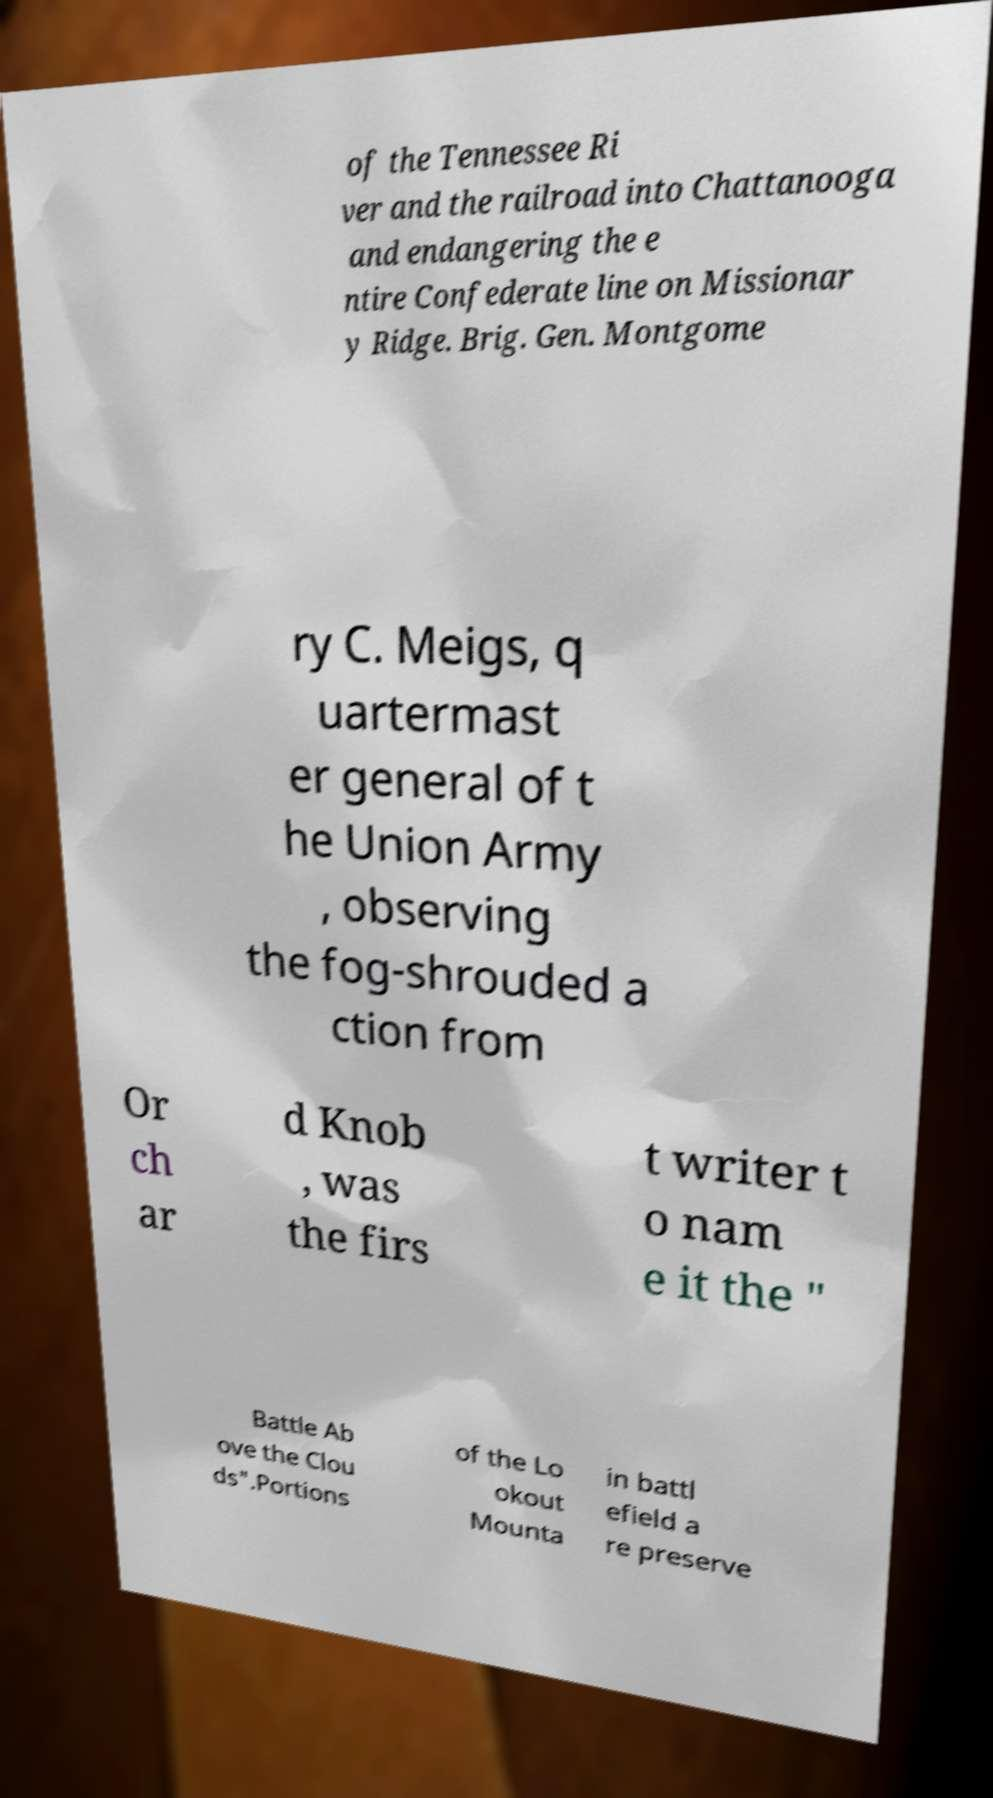Can you accurately transcribe the text from the provided image for me? of the Tennessee Ri ver and the railroad into Chattanooga and endangering the e ntire Confederate line on Missionar y Ridge. Brig. Gen. Montgome ry C. Meigs, q uartermast er general of t he Union Army , observing the fog-shrouded a ction from Or ch ar d Knob , was the firs t writer t o nam e it the " Battle Ab ove the Clou ds".Portions of the Lo okout Mounta in battl efield a re preserve 